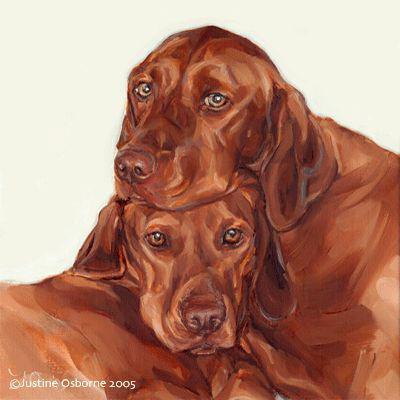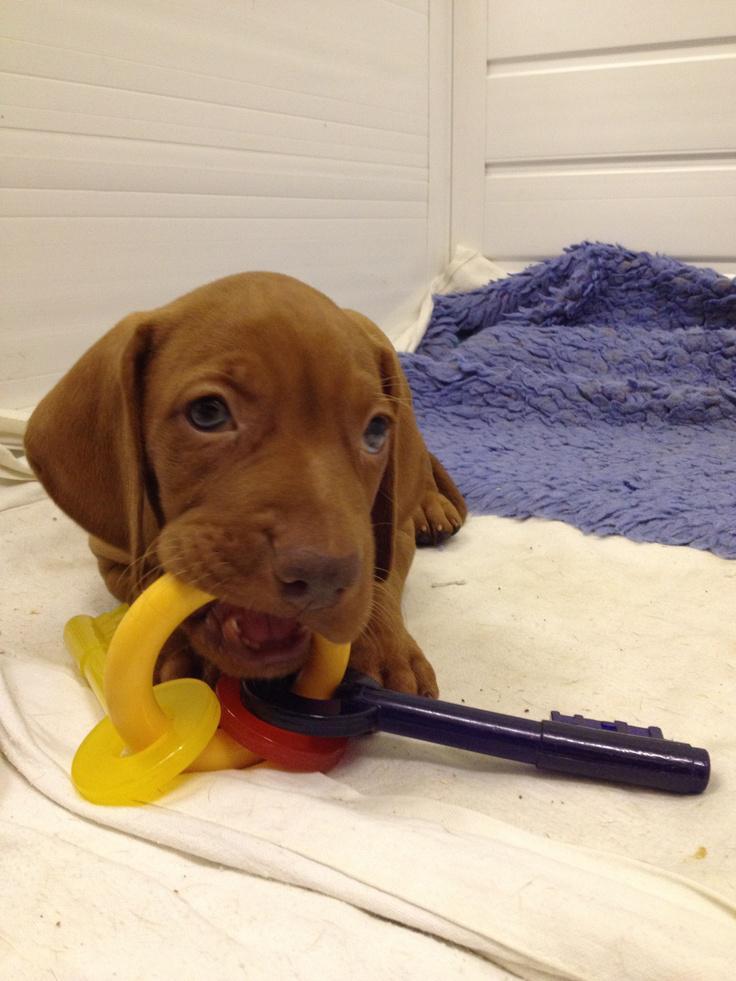The first image is the image on the left, the second image is the image on the right. Given the left and right images, does the statement "A Vizsla dog is lying on a blanket." hold true? Answer yes or no. Yes. The first image is the image on the left, the second image is the image on the right. Considering the images on both sides, is "Each image contains a single red-orange dog, and the right image contains an upward-gazing dog in a sitting pose with a toy stuffed animal by one foot." valid? Answer yes or no. No. 